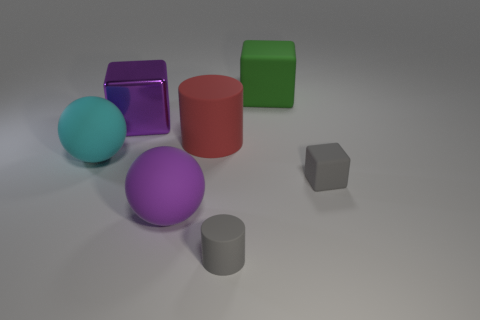Add 2 big green matte objects. How many objects exist? 9 Subtract all balls. How many objects are left? 5 Add 7 green objects. How many green objects are left? 8 Add 4 big purple rubber cylinders. How many big purple rubber cylinders exist? 4 Subtract 0 yellow balls. How many objects are left? 7 Subtract all big rubber balls. Subtract all big red objects. How many objects are left? 4 